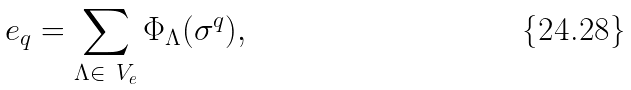Convert formula to latex. <formula><loc_0><loc_0><loc_500><loc_500>e _ { q } = \sum _ { \Lambda \in \ V _ { e } } \Phi _ { \Lambda } ( \sigma ^ { q } ) ,</formula> 